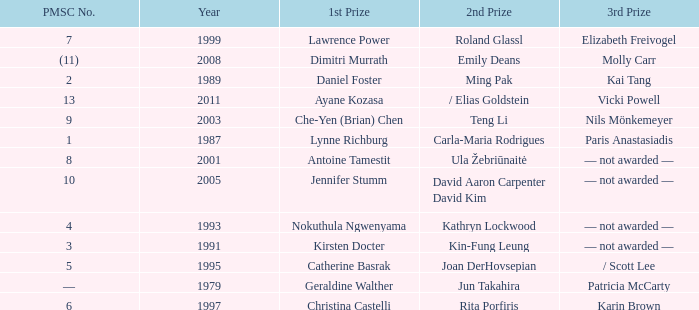What is the earliest year in which the 1st price went to Che-Yen (Brian) Chen? 2003.0. 